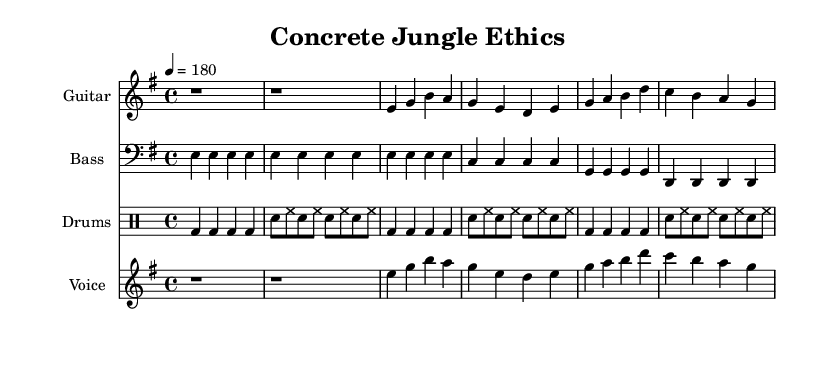What is the key signature of this music? The key signature is indicated by the number of sharps or flats at the beginning of the staff. In this case, the music is in E minor, which has one sharp (F#).
Answer: E minor What is the time signature? The time signature is found at the beginning of the staff, which shows how many beats are in a measure. Here, it is 4/4, meaning there are four beats per measure.
Answer: 4/4 What is the tempo marking? The tempo marking provides the speed of the piece, indicated as a number and a term. In this sheet, the tempo is set at 180 beats per minute.
Answer: 180 How many verses are there in the lyrics? By examining the structure of the lyrics under the voice part, there are two sections labeled as verse and chorus, indicating one verse followed by one chorus.
Answer: 1 What musical instrument is featured in the score? The instrument names at the top of each staff show the types of instruments playing in the piece. The main instrument highlighted is the guitar.
Answer: Guitar What thematic concern is presented in the lyrics? The lyrics discuss abstract concepts like morality and choice, showcased through phrases about ethics in urban settings. The specific focus here is navigating moral choices.
Answer: Morality How is the rhythm characterized in the verses? The verse is described by observing the note durations in the staff. The rhythm features a mix of quarter notes and eighth notes, typical in punk music, contributing to a driving energy.
Answer: Driving energy 